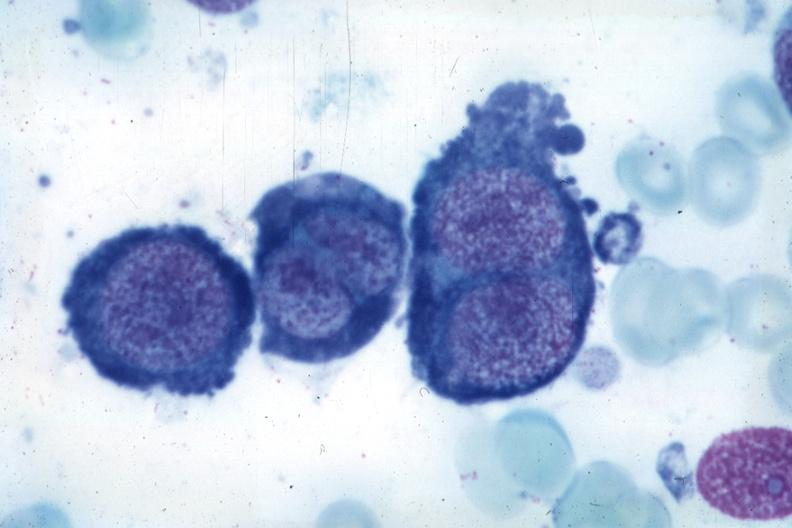what is present?
Answer the question using a single word or phrase. Megaloblasts pernicious anemia 